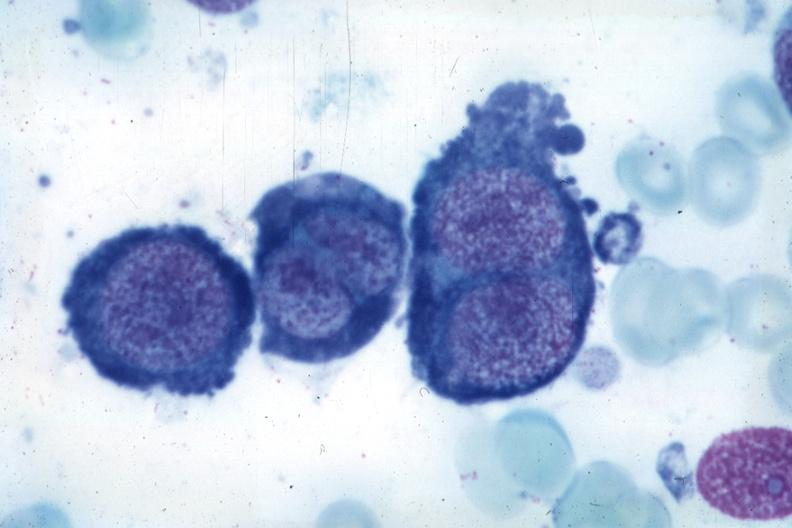what is present?
Answer the question using a single word or phrase. Megaloblasts pernicious anemia 